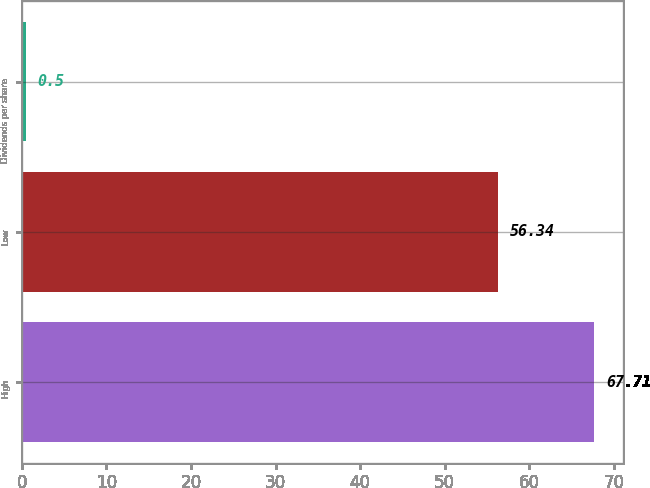Convert chart to OTSL. <chart><loc_0><loc_0><loc_500><loc_500><bar_chart><fcel>High<fcel>Low<fcel>Dividends per share<nl><fcel>67.71<fcel>56.34<fcel>0.5<nl></chart> 